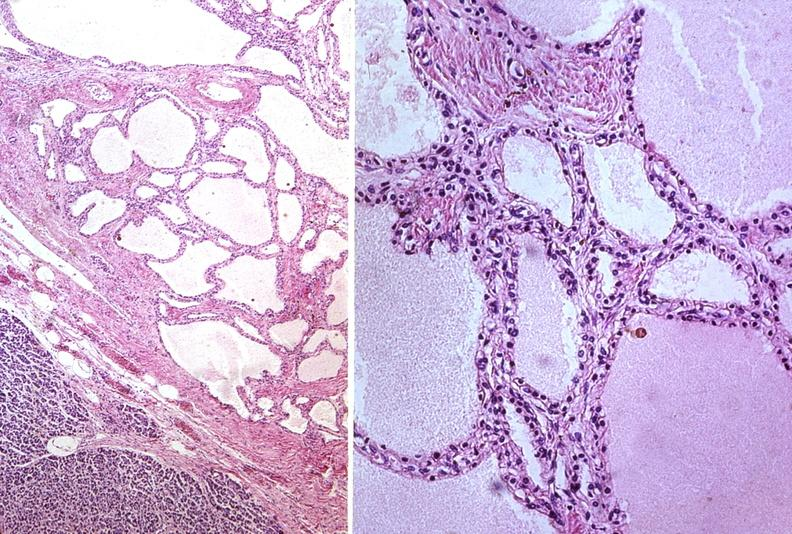s bread-loaf slices into prostate gland present?
Answer the question using a single word or phrase. No 